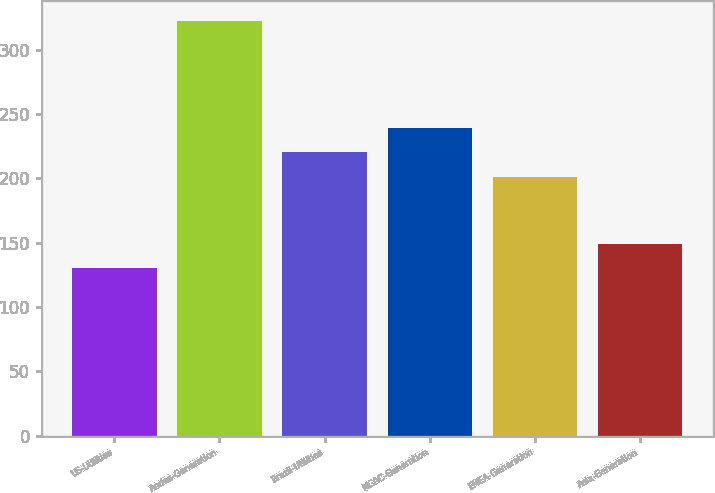Convert chart. <chart><loc_0><loc_0><loc_500><loc_500><bar_chart><fcel>US-Utilities<fcel>Andes-Generation<fcel>Brazil-Utilities<fcel>MCAC-Generation<fcel>EMEA-Generation<fcel>Asia-Generation<nl><fcel>130<fcel>322<fcel>220.2<fcel>239.4<fcel>201<fcel>149.2<nl></chart> 